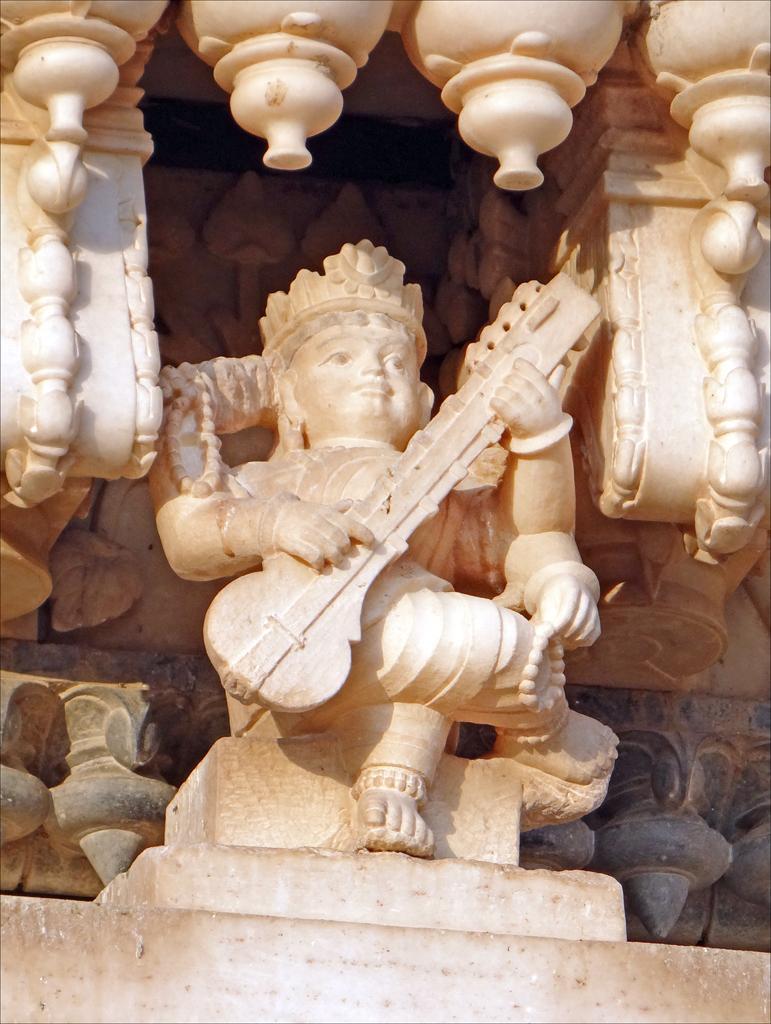How would you summarize this image in a sentence or two? There is a sculpture and an idol in the image. 